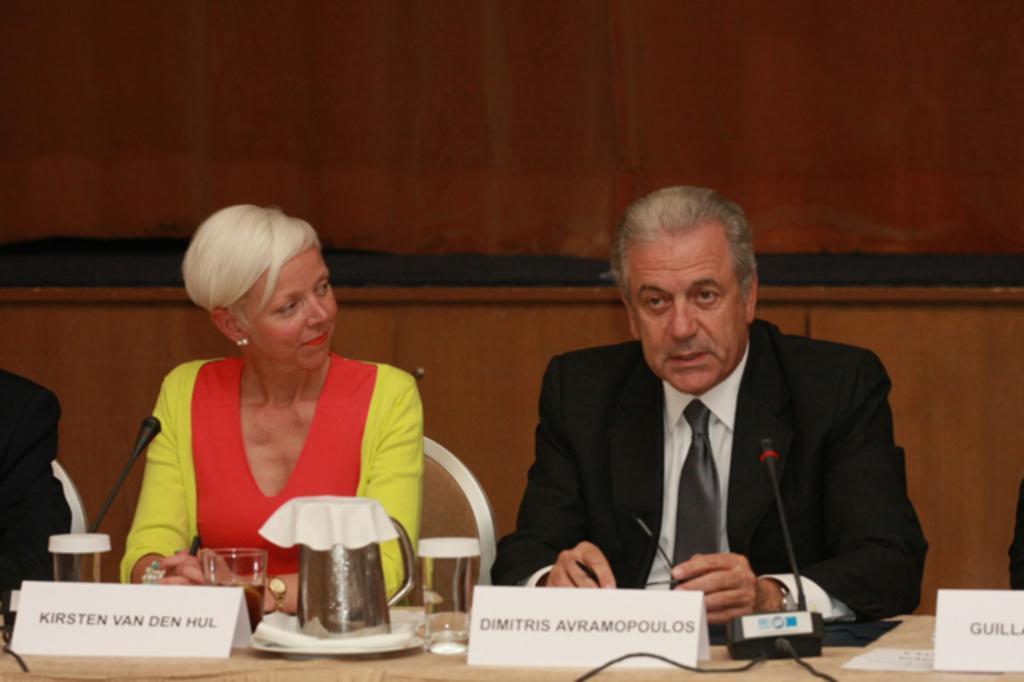Could you give a brief overview of what you see in this image? In this image we can see a man and woman is sitting on a white color chair. In front of them table is there. On table name plate, glasses, jug and mice are there. Man is wearing black color coat with white shirt and woman is wearing orange and yellow color dress. Behind them wooden wall is there. 